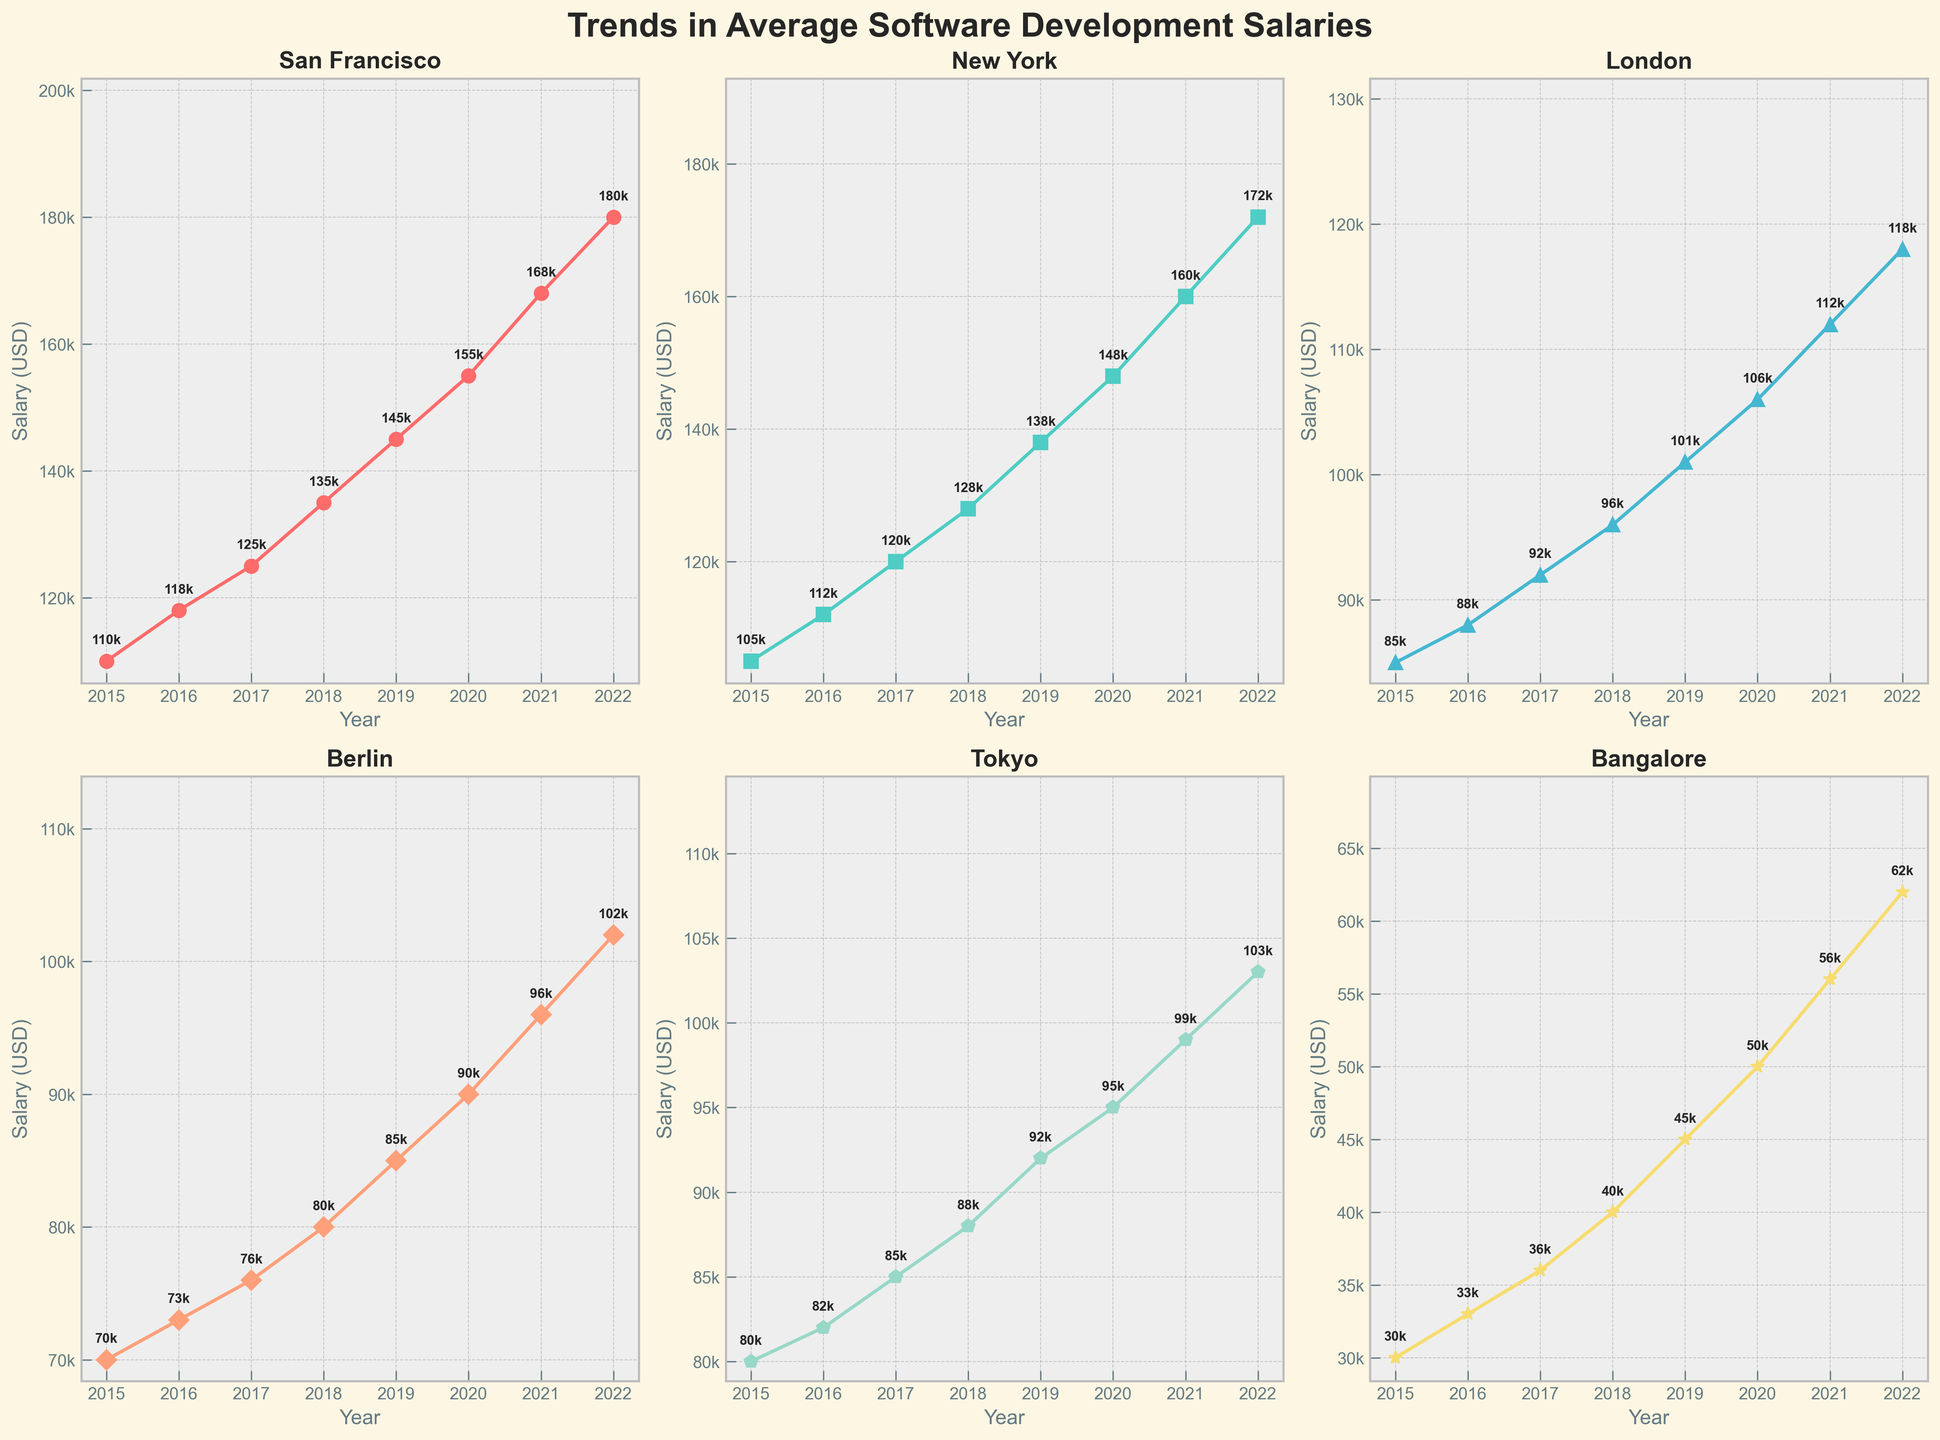Which city has the highest average salary in 2022? The line chart for each city indicates that San Francisco has the highest average salary in 2022 at $180,000.
Answer: San Francisco How did the average salary in Berlin change from 2017 to 2019? The average salary in Berlin went from $76,000 in 2017 to $85,000 in 2019. The difference is $85,000 - $76,000 = $9,000.
Answer: Increased by $9,000 Which city had the lowest average salary growth from 2015 to 2022? Bangalore had the lowest average salary growth from $30,000 in 2015 to $62,000 in 2022, which is a growth of $62,000 - $30,000 = $32,000.
Answer: Bangalore What is the average salary in London in 2018 and how does it compare to the salary in 2017? For London, the average salary in 2018 is $96,000. In 2017, it was $92,000. So, the difference is $96,000 - $92,000 = $4,000.
Answer: Increased by $4,000 Between which two consecutive years did New York see the greatest increase in average salary? To find the greatest increase, compare successive years. From 2020 to 2021, New York's salary increased from $148,000 to $160,000, a difference of $160,000 - $148,000 = $12,000, which is the greatest increase.
Answer: 2020 to 2021 What is the trend in average salaries for Tokyo from 2015 to 2022? The line chart for Tokyo shows a steady upward trend from $80,000 in 2015 to $103,000 in 2022.
Answer: Increasing trend How does the salary in San Francisco in 2021 compare to the salary in London in 2022? In 2021, the salary in San Francisco is $168,000, whereas in London in 2022 it is $118,000. Thus, $168,000 - $118,000 = $50,000 difference.
Answer: San Francisco was $50,000 higher Which city shows the most consistent year-over-year salary increase? By examining the slopes of the lines, San Francisco shows the most consistent and highest year-over-year salary increase across all years.
Answer: San Francisco What was the percentage increase in average salary for Bangalore from 2019 to 2022? The salary in Bangalore increased from $45,000 in 2019 to $62,000 in 2022. The percentage increase is (($62,000 - $45,000) / $45,000) * 100 = 37.78%.
Answer: 37.78% 